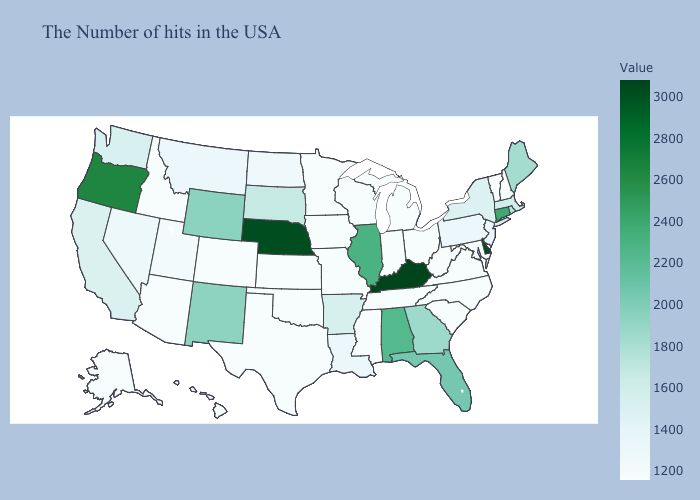Does North Dakota have the highest value in the USA?
Be succinct. No. Does Nevada have the highest value in the USA?
Be succinct. No. Does Arizona have the highest value in the USA?
Be succinct. No. Does Pennsylvania have the lowest value in the Northeast?
Answer briefly. No. Which states have the highest value in the USA?
Write a very short answer. Kentucky. 